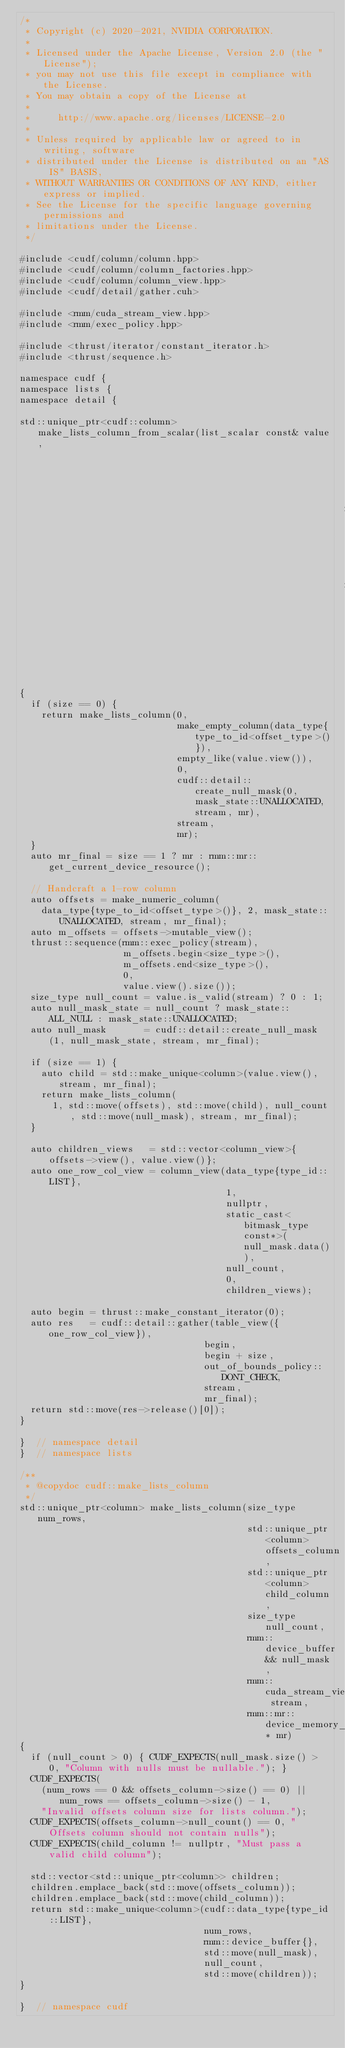<code> <loc_0><loc_0><loc_500><loc_500><_Cuda_>/*
 * Copyright (c) 2020-2021, NVIDIA CORPORATION.
 *
 * Licensed under the Apache License, Version 2.0 (the "License");
 * you may not use this file except in compliance with the License.
 * You may obtain a copy of the License at
 *
 *     http://www.apache.org/licenses/LICENSE-2.0
 *
 * Unless required by applicable law or agreed to in writing, software
 * distributed under the License is distributed on an "AS IS" BASIS,
 * WITHOUT WARRANTIES OR CONDITIONS OF ANY KIND, either express or implied.
 * See the License for the specific language governing permissions and
 * limitations under the License.
 */

#include <cudf/column/column.hpp>
#include <cudf/column/column_factories.hpp>
#include <cudf/column/column_view.hpp>
#include <cudf/detail/gather.cuh>

#include <rmm/cuda_stream_view.hpp>
#include <rmm/exec_policy.hpp>

#include <thrust/iterator/constant_iterator.h>
#include <thrust/sequence.h>

namespace cudf {
namespace lists {
namespace detail {

std::unique_ptr<cudf::column> make_lists_column_from_scalar(list_scalar const& value,
                                                            size_type size,
                                                            rmm::cuda_stream_view stream,
                                                            rmm::mr::device_memory_resource* mr)
{
  if (size == 0) {
    return make_lists_column(0,
                             make_empty_column(data_type{type_to_id<offset_type>()}),
                             empty_like(value.view()),
                             0,
                             cudf::detail::create_null_mask(0, mask_state::UNALLOCATED, stream, mr),
                             stream,
                             mr);
  }
  auto mr_final = size == 1 ? mr : rmm::mr::get_current_device_resource();

  // Handcraft a 1-row column
  auto offsets = make_numeric_column(
    data_type{type_to_id<offset_type>()}, 2, mask_state::UNALLOCATED, stream, mr_final);
  auto m_offsets = offsets->mutable_view();
  thrust::sequence(rmm::exec_policy(stream),
                   m_offsets.begin<size_type>(),
                   m_offsets.end<size_type>(),
                   0,
                   value.view().size());
  size_type null_count = value.is_valid(stream) ? 0 : 1;
  auto null_mask_state = null_count ? mask_state::ALL_NULL : mask_state::UNALLOCATED;
  auto null_mask       = cudf::detail::create_null_mask(1, null_mask_state, stream, mr_final);

  if (size == 1) {
    auto child = std::make_unique<column>(value.view(), stream, mr_final);
    return make_lists_column(
      1, std::move(offsets), std::move(child), null_count, std::move(null_mask), stream, mr_final);
  }

  auto children_views   = std::vector<column_view>{offsets->view(), value.view()};
  auto one_row_col_view = column_view(data_type{type_id::LIST},
                                      1,
                                      nullptr,
                                      static_cast<bitmask_type const*>(null_mask.data()),
                                      null_count,
                                      0,
                                      children_views);

  auto begin = thrust::make_constant_iterator(0);
  auto res   = cudf::detail::gather(table_view({one_row_col_view}),
                                  begin,
                                  begin + size,
                                  out_of_bounds_policy::DONT_CHECK,
                                  stream,
                                  mr_final);
  return std::move(res->release()[0]);
}

}  // namespace detail
}  // namespace lists

/**
 * @copydoc cudf::make_lists_column
 */
std::unique_ptr<column> make_lists_column(size_type num_rows,
                                          std::unique_ptr<column> offsets_column,
                                          std::unique_ptr<column> child_column,
                                          size_type null_count,
                                          rmm::device_buffer&& null_mask,
                                          rmm::cuda_stream_view stream,
                                          rmm::mr::device_memory_resource* mr)
{
  if (null_count > 0) { CUDF_EXPECTS(null_mask.size() > 0, "Column with nulls must be nullable."); }
  CUDF_EXPECTS(
    (num_rows == 0 && offsets_column->size() == 0) || num_rows == offsets_column->size() - 1,
    "Invalid offsets column size for lists column.");
  CUDF_EXPECTS(offsets_column->null_count() == 0, "Offsets column should not contain nulls");
  CUDF_EXPECTS(child_column != nullptr, "Must pass a valid child column");

  std::vector<std::unique_ptr<column>> children;
  children.emplace_back(std::move(offsets_column));
  children.emplace_back(std::move(child_column));
  return std::make_unique<column>(cudf::data_type{type_id::LIST},
                                  num_rows,
                                  rmm::device_buffer{},
                                  std::move(null_mask),
                                  null_count,
                                  std::move(children));
}

}  // namespace cudf
</code> 